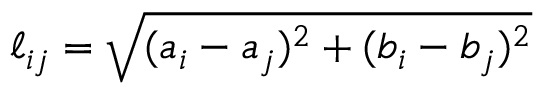<formula> <loc_0><loc_0><loc_500><loc_500>\ell _ { i j } = \sqrt { ( a _ { i } - a _ { j } ) ^ { 2 } + ( b _ { i } - b _ { j } ) ^ { 2 } }</formula> 